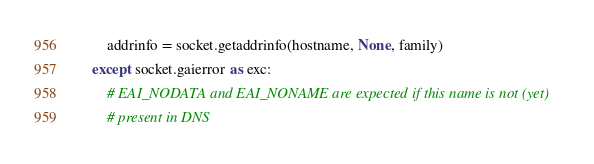Convert code to text. <code><loc_0><loc_0><loc_500><loc_500><_Python_>        addrinfo = socket.getaddrinfo(hostname, None, family)
    except socket.gaierror as exc:
        # EAI_NODATA and EAI_NONAME are expected if this name is not (yet)
        # present in DNS</code> 